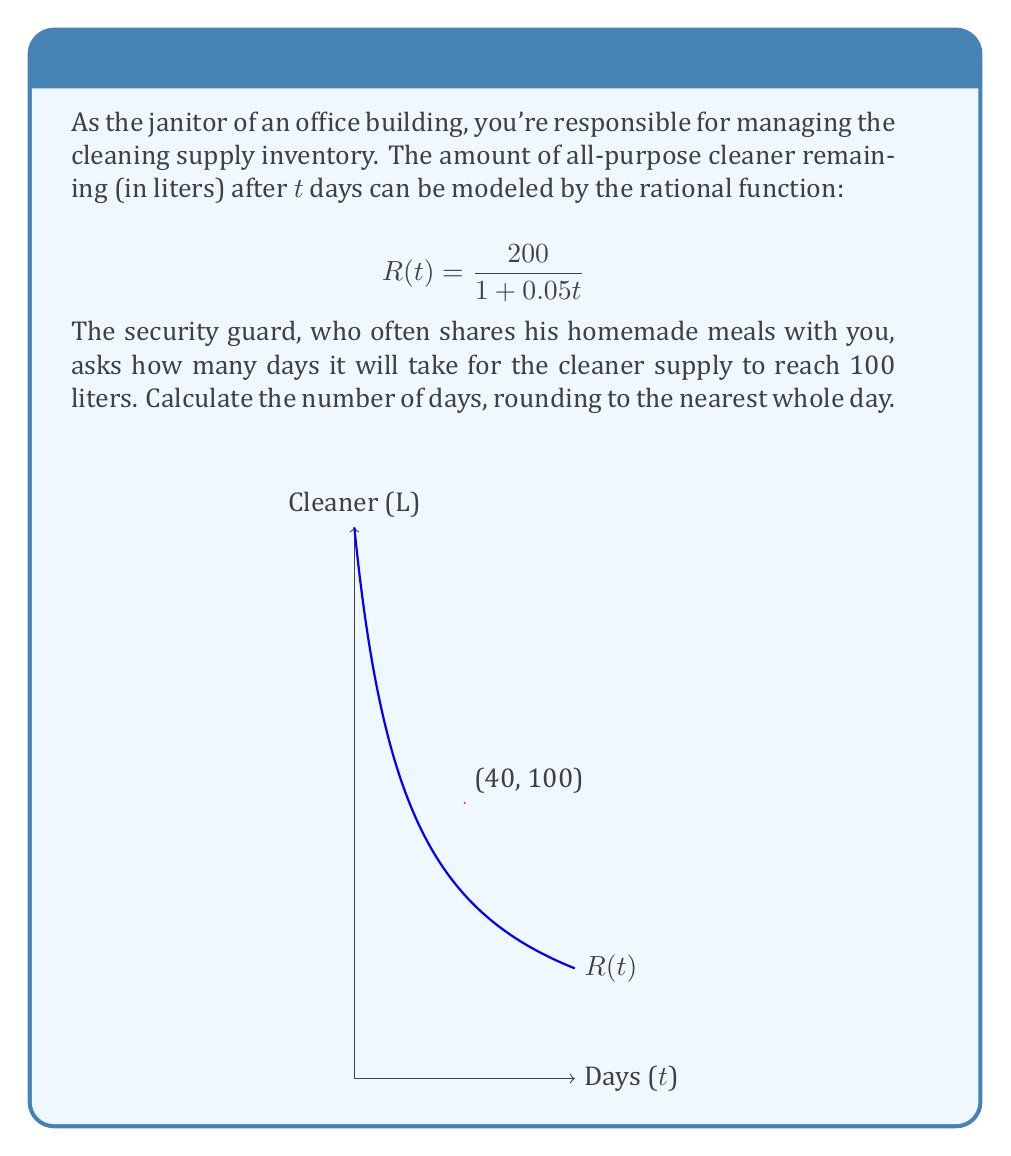Solve this math problem. Let's approach this step-by-step:

1) We need to find t when R(t) = 100 liters.

2) Set up the equation:
   $$100 = \frac{200}{1 + 0.05t}$$

3) Multiply both sides by (1 + 0.05t):
   $$100(1 + 0.05t) = 200$$

4) Expand the left side:
   $$100 + 5t = 200$$

5) Subtract 100 from both sides:
   $$5t = 100$$

6) Divide both sides by 5:
   $$t = 20$$

7) Therefore, it will take exactly 20 days for the cleaner supply to reach 100 liters.

8) The question asks to round to the nearest whole day, but 20 is already a whole number, so no rounding is necessary.
Answer: 20 days 